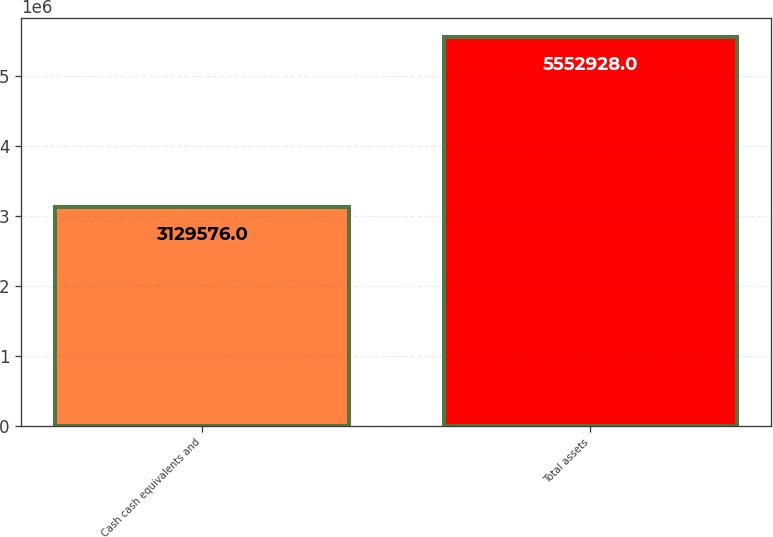Convert chart to OTSL. <chart><loc_0><loc_0><loc_500><loc_500><bar_chart><fcel>Cash cash equivalents and<fcel>Total assets<nl><fcel>3.12958e+06<fcel>5.55293e+06<nl></chart> 